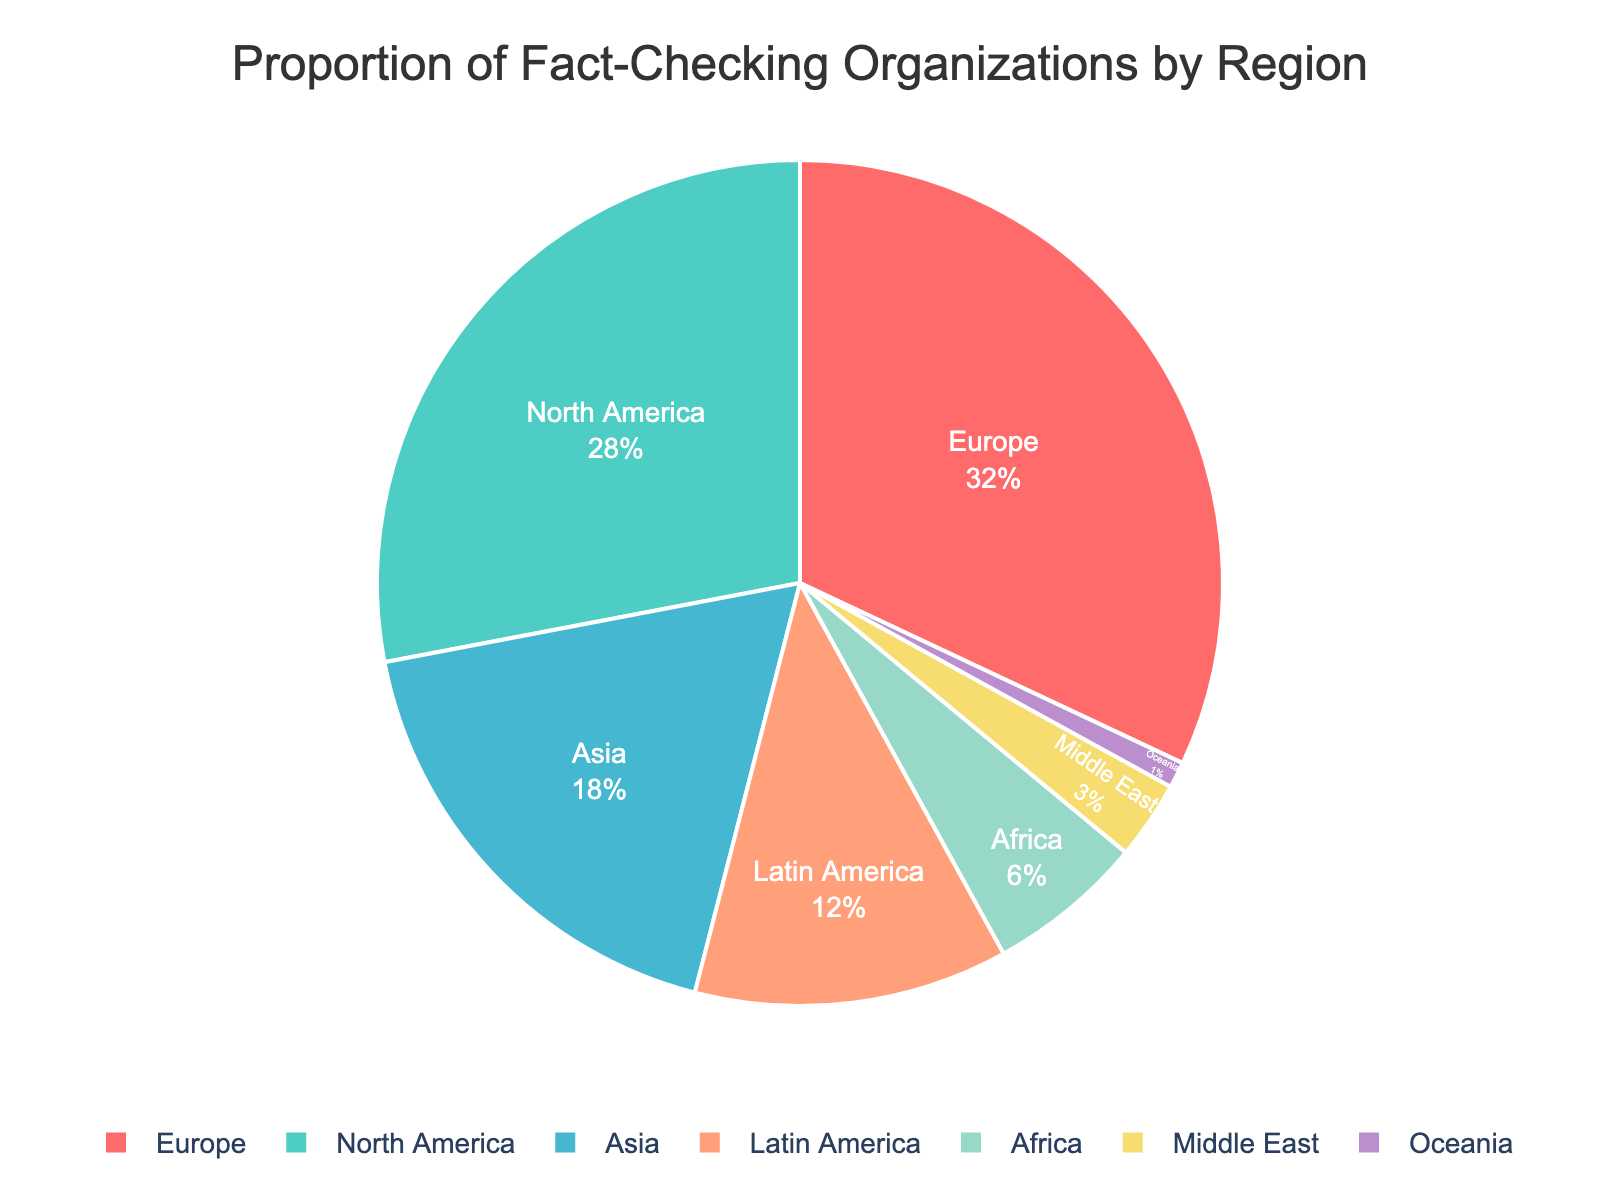What's the region with the highest proportion of fact-checking organizations? The region with the highest proportion is clearly marked in the pie chart by the largest segment. This region is Europe, which has the largest percentage labeled.
Answer: Europe Which region has the smallest proportion of fact-checking organizations? The region with the smallest proportion is the smallest segment in the pie chart, which is labeled as Oceania.
Answer: Oceania What's the combined percentage of fact-checking organizations in North America and Europe? To find the combined percentage, add the percentages for North America and Europe: 28% (North America) + 32% (Europe) = 60%.
Answer: 60% How does the proportion of fact-checking organizations in Asia compare to Latin America? Asia's proportion is 18% while Latin America's proportion is 12%. Comparing these, Asia has a higher proportion than Latin America.
Answer: Asia has a higher proportion What is the difference in percentage points between the regions with the highest and lowest proportions? Calculate the difference between Europe (32%) and Oceania (1%): 32% - 1% = 31%.
Answer: 31% Which regions have a proportion of fact-checking organizations that are less than 10%? From the chart, the proportions less than 10% are Africa (6%), Middle East (3%), and Oceania (1%).
Answer: Africa, Middle East, Oceania What's the total percentage of fact-checking organizations in regions other than Europe and North America? Subtract the combined percentage of Europe and North America from 100%: 100% - (32% + 28%) = 40%.
Answer: 40% If you combine the percentages of Africa and the Middle East, how do they compare to Latin America? Combining Africa (6%) and the Middle East (3%) gives 6% + 3% = 9%, which is less than Latin America’s 12%.
Answer: Less than Latin America What's the average percentage of the three regions with the lowest proportions? The three regions with the lowest proportions are Oceania (1%), Middle East (3%), and Africa (6%). The average is (1% + 3% + 6%) / 3 = 10% / 3 ≈ 3.33%.
Answer: 3.33% In terms of color representation, which region's segment is colored green? Based on the custom color palette, the color green corresponds to the exact color match of Europe in the pie chart.
Answer: Europe 